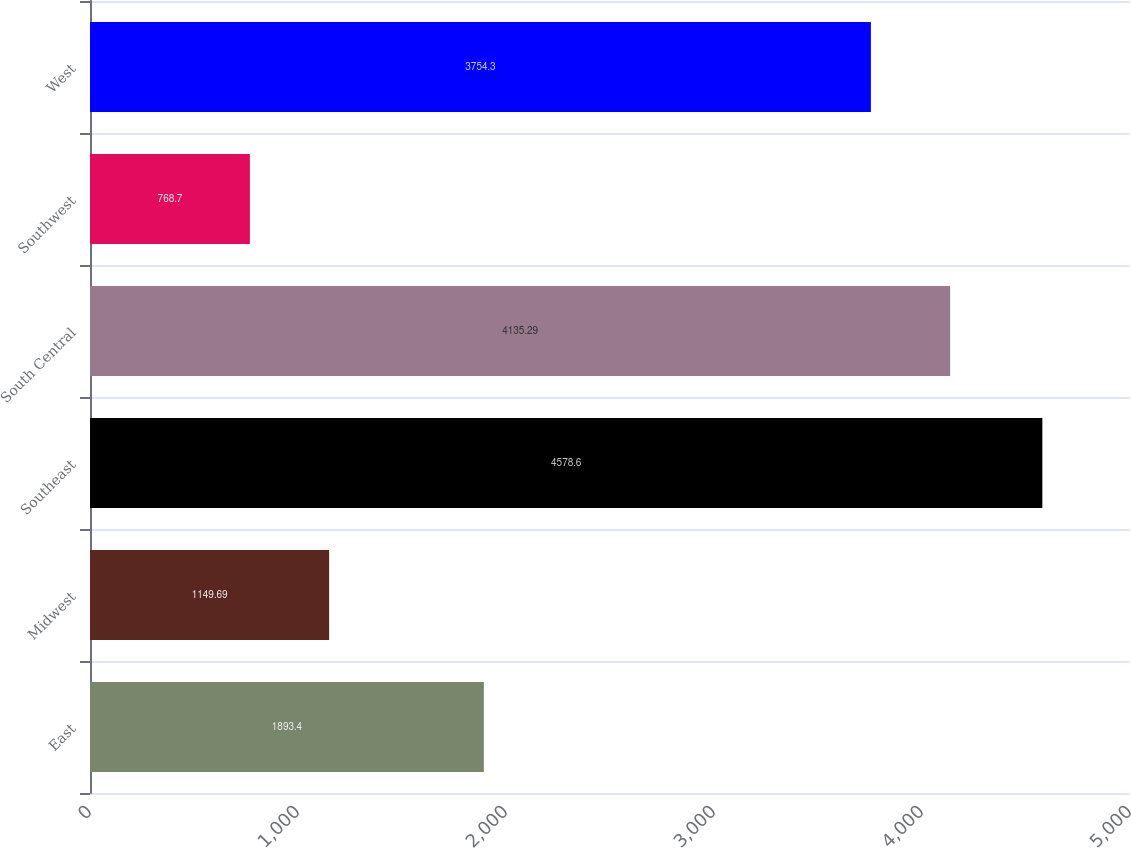<chart> <loc_0><loc_0><loc_500><loc_500><bar_chart><fcel>East<fcel>Midwest<fcel>Southeast<fcel>South Central<fcel>Southwest<fcel>West<nl><fcel>1893.4<fcel>1149.69<fcel>4578.6<fcel>4135.29<fcel>768.7<fcel>3754.3<nl></chart> 